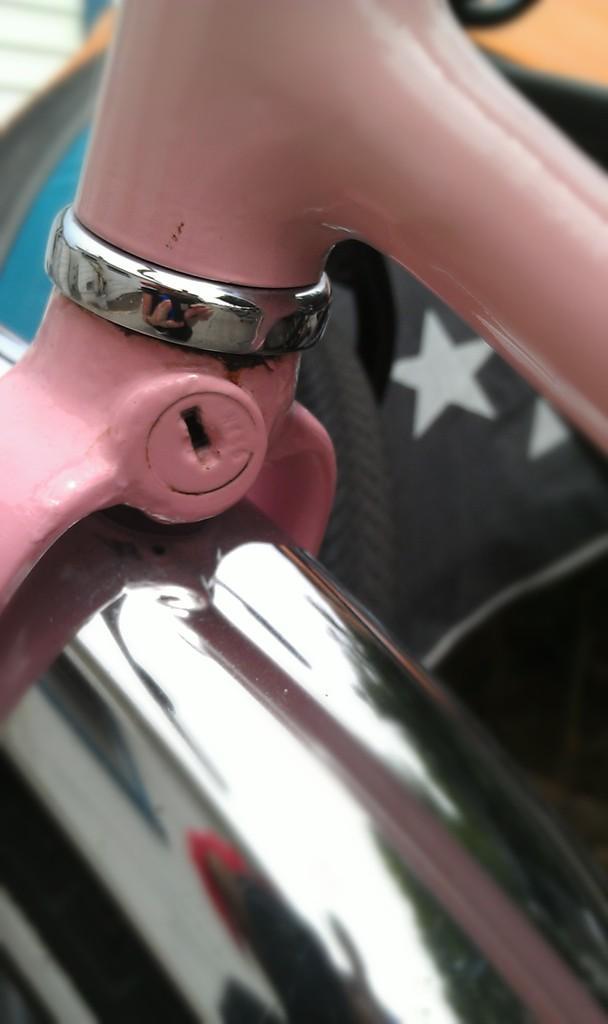Could you give a brief overview of what you see in this image? In this picture we can see there are metal objects and a key panel. 